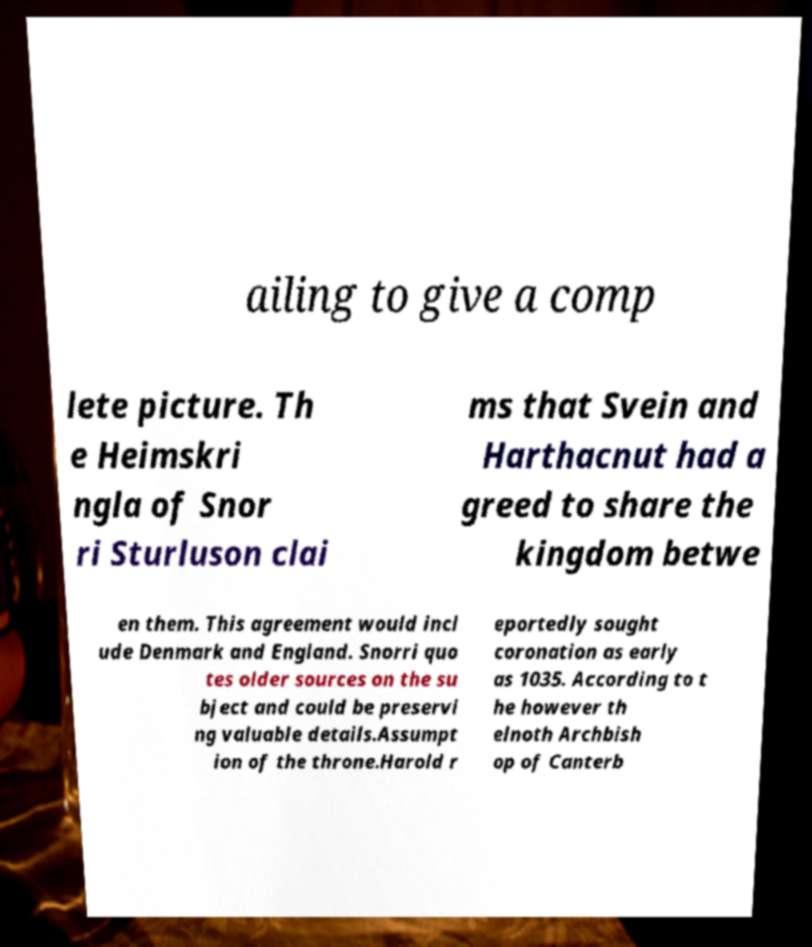Please read and relay the text visible in this image. What does it say? ailing to give a comp lete picture. Th e Heimskri ngla of Snor ri Sturluson clai ms that Svein and Harthacnut had a greed to share the kingdom betwe en them. This agreement would incl ude Denmark and England. Snorri quo tes older sources on the su bject and could be preservi ng valuable details.Assumpt ion of the throne.Harold r eportedly sought coronation as early as 1035. According to t he however th elnoth Archbish op of Canterb 